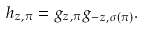Convert formula to latex. <formula><loc_0><loc_0><loc_500><loc_500>h _ { z , \pi } = g _ { z , \pi } g _ { - z , \sigma ( \pi ) } .</formula> 